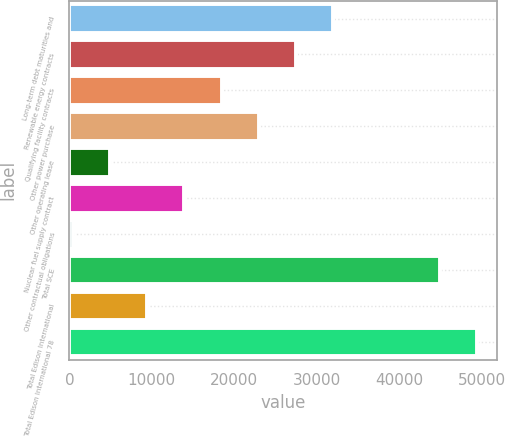Convert chart to OTSL. <chart><loc_0><loc_0><loc_500><loc_500><bar_chart><fcel>Long-term debt maturities and<fcel>Renewable energy contracts<fcel>Qualifying facility contracts<fcel>Other power purchase<fcel>Other operating lease<fcel>Nuclear fuel supply contract<fcel>Other contractual obligations<fcel>Total SCE<fcel>Total Edison International<fcel>Total Edison International 78<nl><fcel>31984.4<fcel>27474.2<fcel>18453.8<fcel>22964<fcel>4923.2<fcel>13943.6<fcel>413<fcel>44897<fcel>9433.4<fcel>49407.2<nl></chart> 